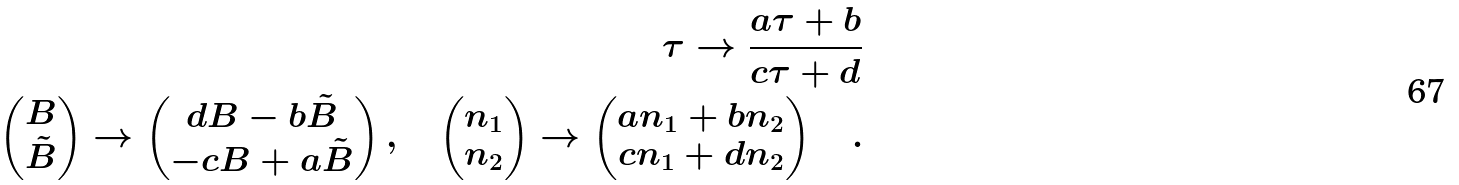Convert formula to latex. <formula><loc_0><loc_0><loc_500><loc_500>\tau \to \frac { a \tau + b } { c \tau + d } \\ \begin{pmatrix} B \\ \tilde { B } \end{pmatrix} \to \begin{pmatrix} d B - b \tilde { B } \\ - c B + a \tilde { B } \end{pmatrix} , \quad \begin{pmatrix} n _ { 1 } \\ n _ { 2 } \end{pmatrix} \to \begin{pmatrix} a n _ { 1 } + b n _ { 2 } \\ c n _ { 1 } + d n _ { 2 } \end{pmatrix} \quad .</formula> 